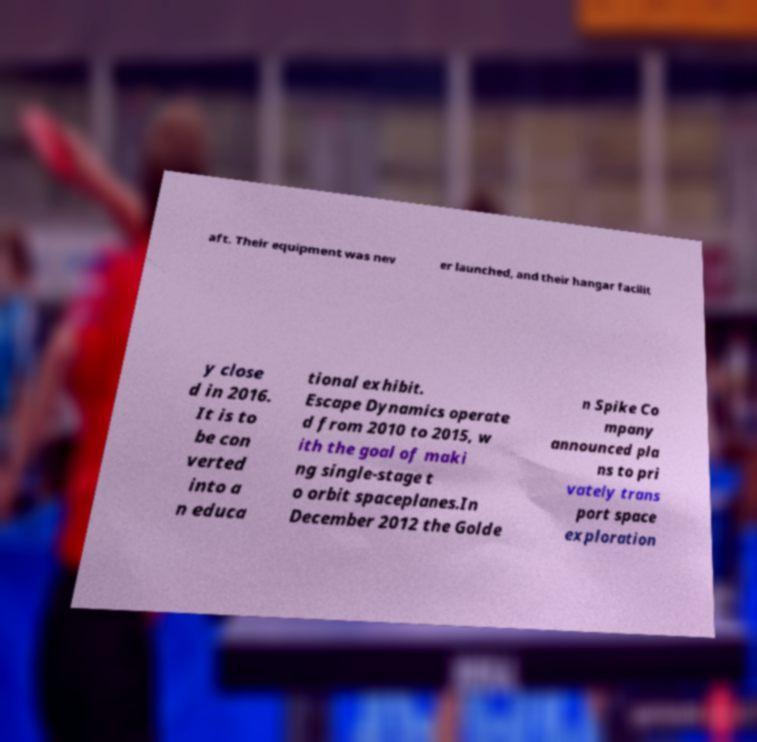What messages or text are displayed in this image? I need them in a readable, typed format. aft. Their equipment was nev er launched, and their hangar facilit y close d in 2016. It is to be con verted into a n educa tional exhibit. Escape Dynamics operate d from 2010 to 2015, w ith the goal of maki ng single-stage t o orbit spaceplanes.In December 2012 the Golde n Spike Co mpany announced pla ns to pri vately trans port space exploration 